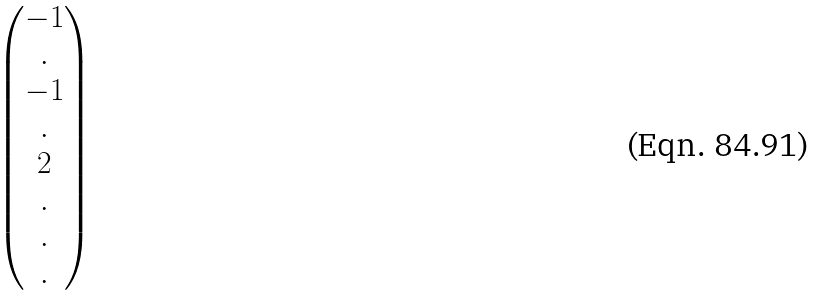<formula> <loc_0><loc_0><loc_500><loc_500>\begin{pmatrix} - 1 \\ . \\ - 1 \\ . \\ 2 \\ . \\ . \\ . \\ \end{pmatrix}</formula> 